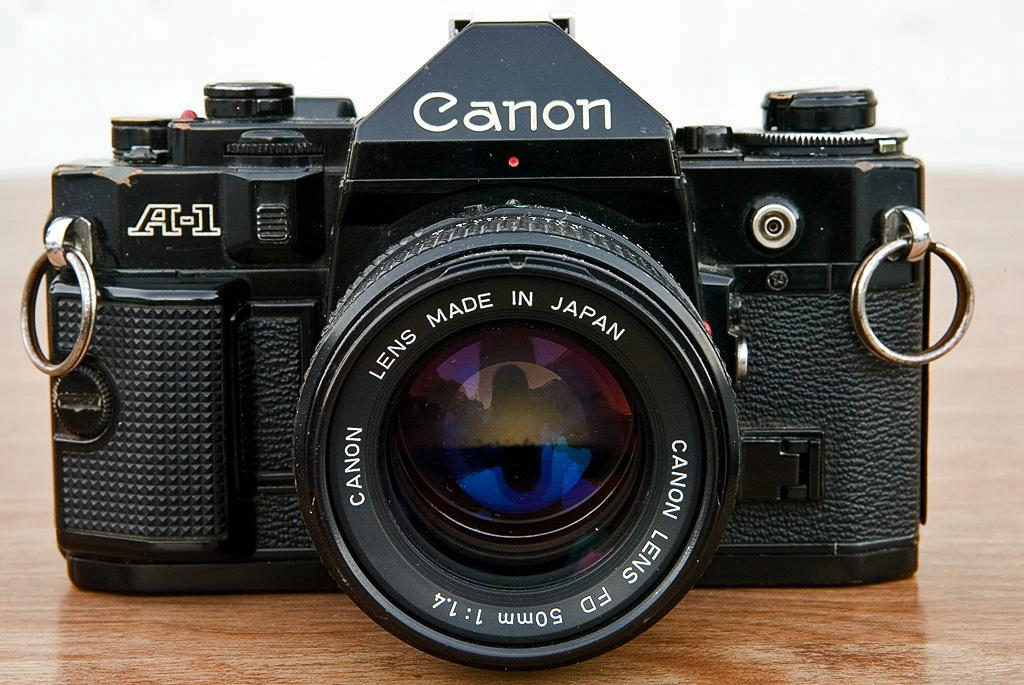What is the main subject of the image? The main subject of the image is a camera. What is the camera placed on? The camera is placed on a wooden object. What type of cup is being used to control the camera in the image? There is no cup present in the image, and the camera is not being controlled by any cup. 